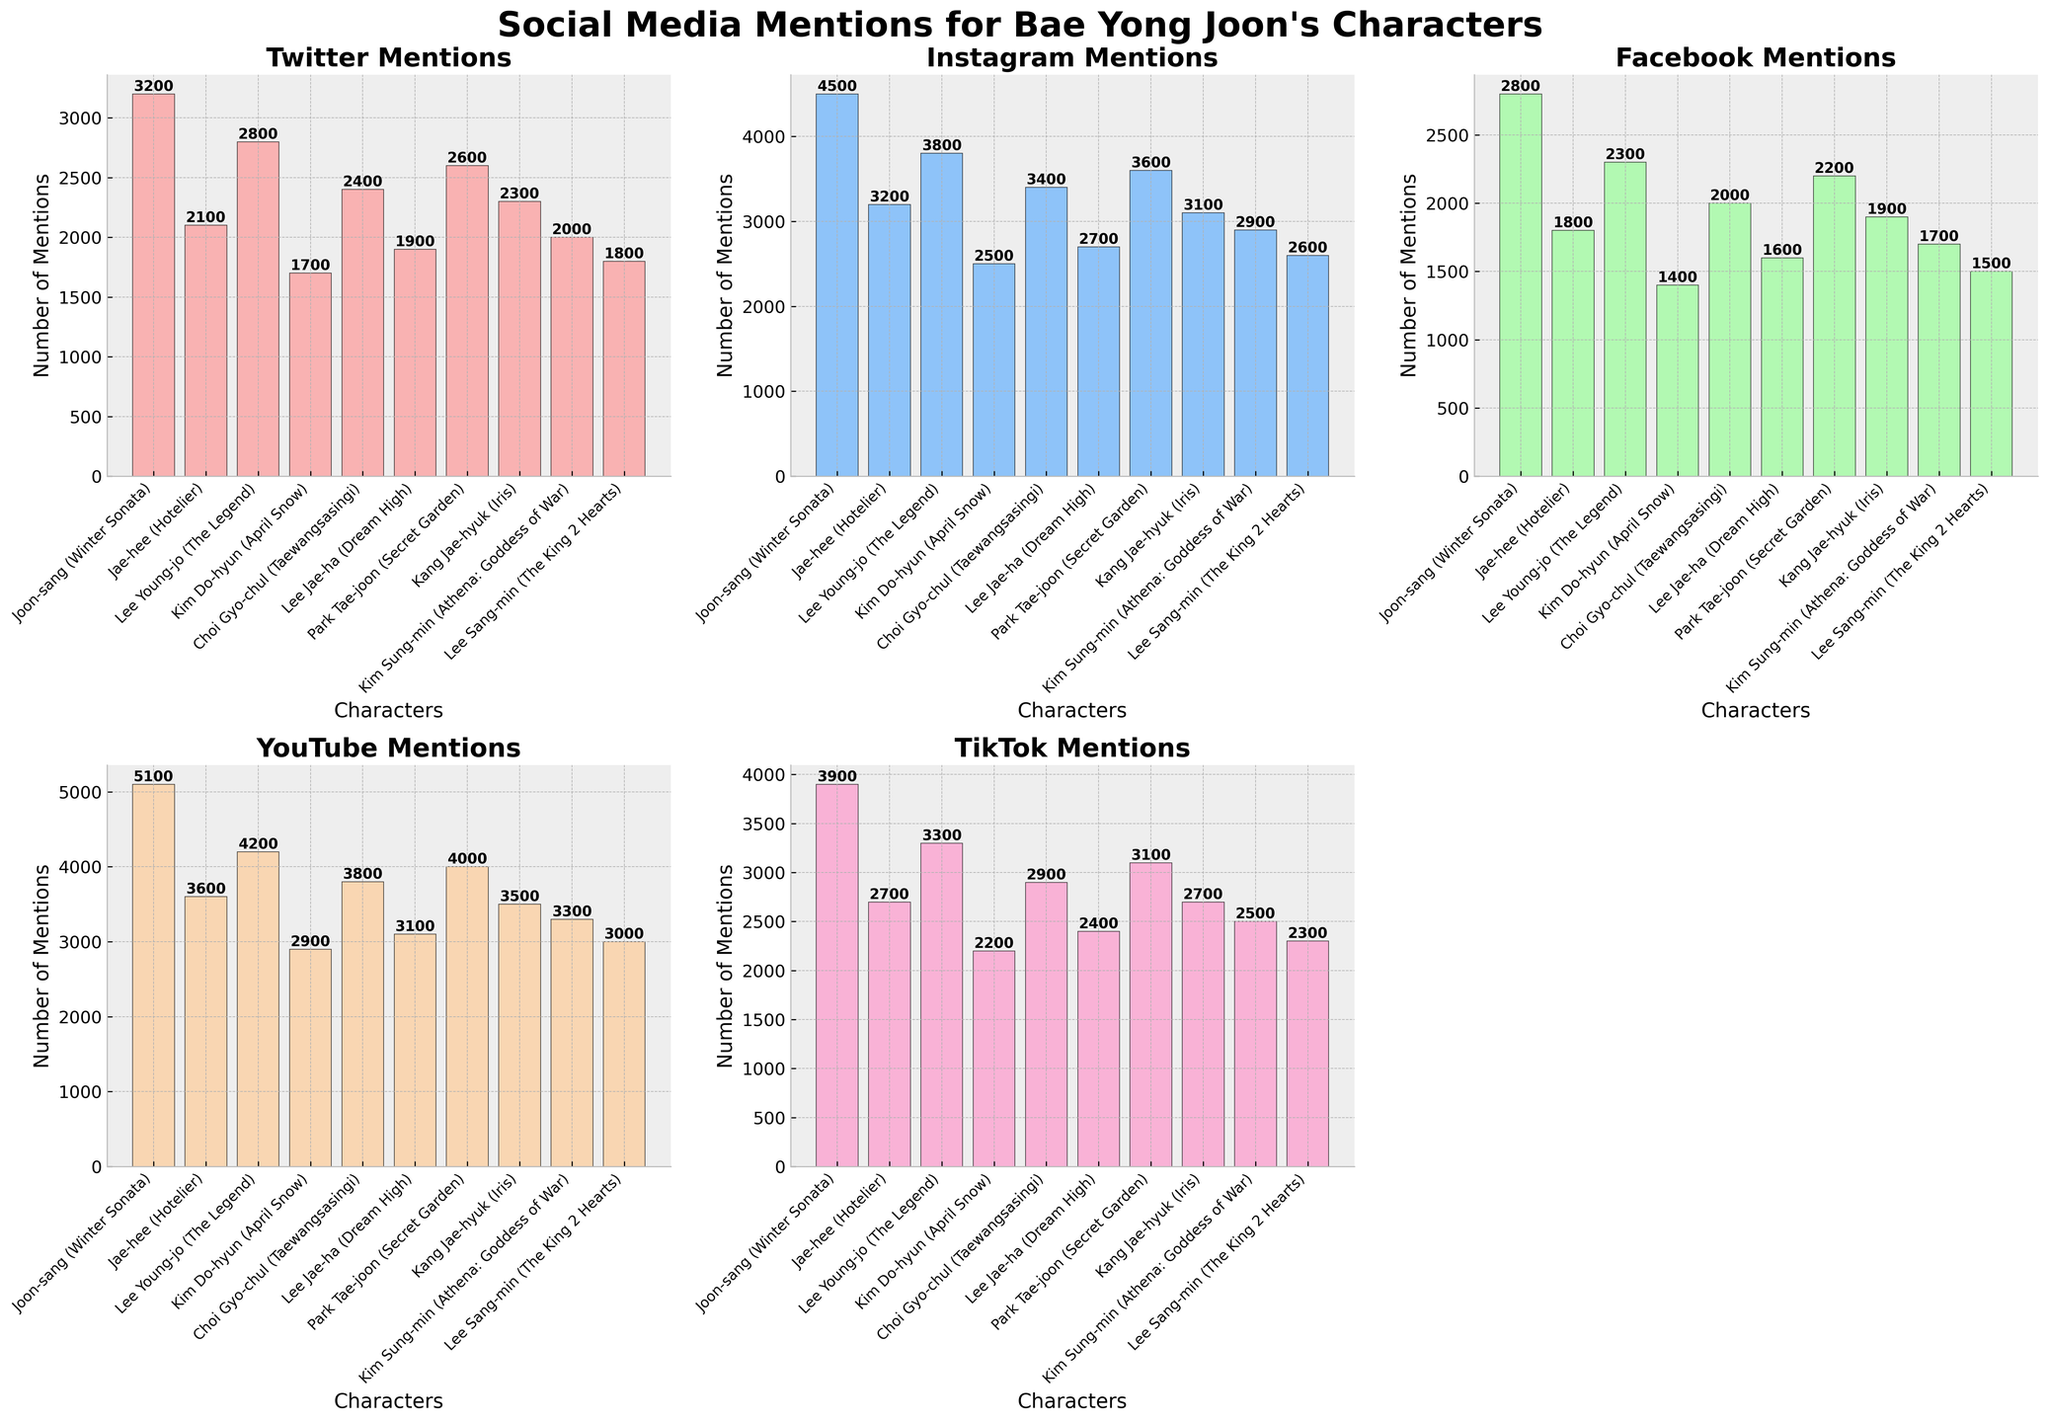What's the character with the highest number of Instagram mentions? Look at the subplot for Instagram and compare the heights of the bars. The tallest bar corresponds to Joon-sang from Winter Sonata with 4500 mentions.
Answer: Joon-sang On which social media platform does Jae-hee (Hotelier) have the lowest number of mentions? Check Jae-hee's mentions across different plots. The lowest value is on Facebook with 1800 mentions.
Answer: Facebook What is the difference in TikTok mentions between Lee Young-jo (The Legend) and Kim Do-hyun (April Snow)? Look at the TikTok subplot and identify the values for Lee Young-jo (3300) and Kim Do-hyun (2200). The difference is 3300 - 2200 = 1100.
Answer: 1100 Which character has more total mentions on YouTube and TikTok: Park Tae-joon (Secret Garden) or Kang Jae-hyuk (Iris)? Sum the YouTube and TikTok mentions for each character. For Park Tae-joon, it's 4000 + 3100 = 7100. For Kang Jae-hyuk, it's 3500 + 2700 = 6200. Park Tae-joon has more mentions in total.
Answer: Park Tae-joon For which character is the number of Twitter mentions closest to the number of Facebook mentions? Compare the difference between Twitter and Facebook mentions for each character. The smallest difference is for Lee Sang-min (The King 2 Hearts) with 1800 Twitter mentions and 1500 Facebook mentions; the difference is 300.
Answer: Lee Sang-min How many mentions are there in total for Instagram across all characters? Sum up the Instagram mentions for all characters. 4500 + 3200 + 3800 + 2500 + 3400 + 2700 + 3600 + 3100 + 2900 + 2600 = 32300.
Answer: 32300 Which platform shows the least variance in mentions for all characters? Compare the range of mentions for each platform. TikTok has the least variance since the highest is 3900 and the lowest is 2200 (range of 1700).
Answer: TikTok Which character has the second-most mentions on Facebook? Look at the Facebook subplot and find the second-highest bar. Lee Young-jo (The Legend) has the second-most mentions with 2300.
Answer: Lee Young-jo What is the average number of YouTube mentions across all characters? Sum the YouTube mentions (5100 + 3600 + 4200 + 2900 + 3800 + 3100 + 4000 + 3500 + 3300 + 3000 = 36500) and divide by the number of characters (10). 36500 / 10 = 3650.
Answer: 3650 